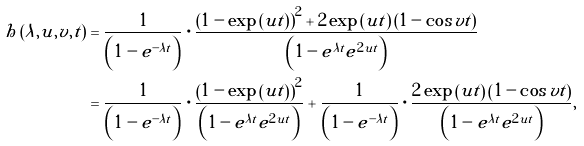Convert formula to latex. <formula><loc_0><loc_0><loc_500><loc_500>h \left ( \lambda , u , v , t \right ) & = \frac { 1 } { \left ( 1 - e ^ { - \lambda t } \right ) } \cdot \frac { \left ( 1 - \exp \left ( u t \right ) \right ) ^ { 2 } + 2 \exp \left ( u t \right ) \left ( 1 - \cos v t \right ) } { \left ( 1 - e ^ { \lambda t } e ^ { 2 u t } \right ) } \\ & = \frac { 1 } { \left ( 1 - e ^ { - \lambda t } \right ) } \cdot \frac { \left ( 1 - \exp \left ( u t \right ) \right ) ^ { 2 } } { \left ( 1 - e ^ { \lambda t } e ^ { 2 u t } \right ) } + \frac { 1 } { \left ( 1 - e ^ { - \lambda t } \right ) } \cdot \frac { 2 \exp \left ( u t \right ) \left ( 1 - \cos v t \right ) } { \left ( 1 - e ^ { \lambda t } e ^ { 2 u t } \right ) } ,</formula> 